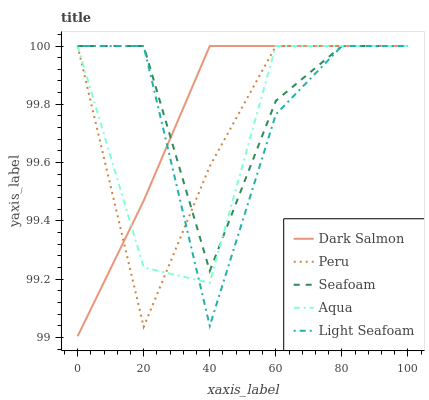Does Aqua have the minimum area under the curve?
Answer yes or no. Yes. Does Seafoam have the maximum area under the curve?
Answer yes or no. Yes. Does Dark Salmon have the minimum area under the curve?
Answer yes or no. No. Does Dark Salmon have the maximum area under the curve?
Answer yes or no. No. Is Dark Salmon the smoothest?
Answer yes or no. Yes. Is Light Seafoam the roughest?
Answer yes or no. Yes. Is Aqua the smoothest?
Answer yes or no. No. Is Aqua the roughest?
Answer yes or no. No. Does Dark Salmon have the lowest value?
Answer yes or no. Yes. Does Aqua have the lowest value?
Answer yes or no. No. Does Seafoam have the highest value?
Answer yes or no. Yes. Does Seafoam intersect Peru?
Answer yes or no. Yes. Is Seafoam less than Peru?
Answer yes or no. No. Is Seafoam greater than Peru?
Answer yes or no. No. 